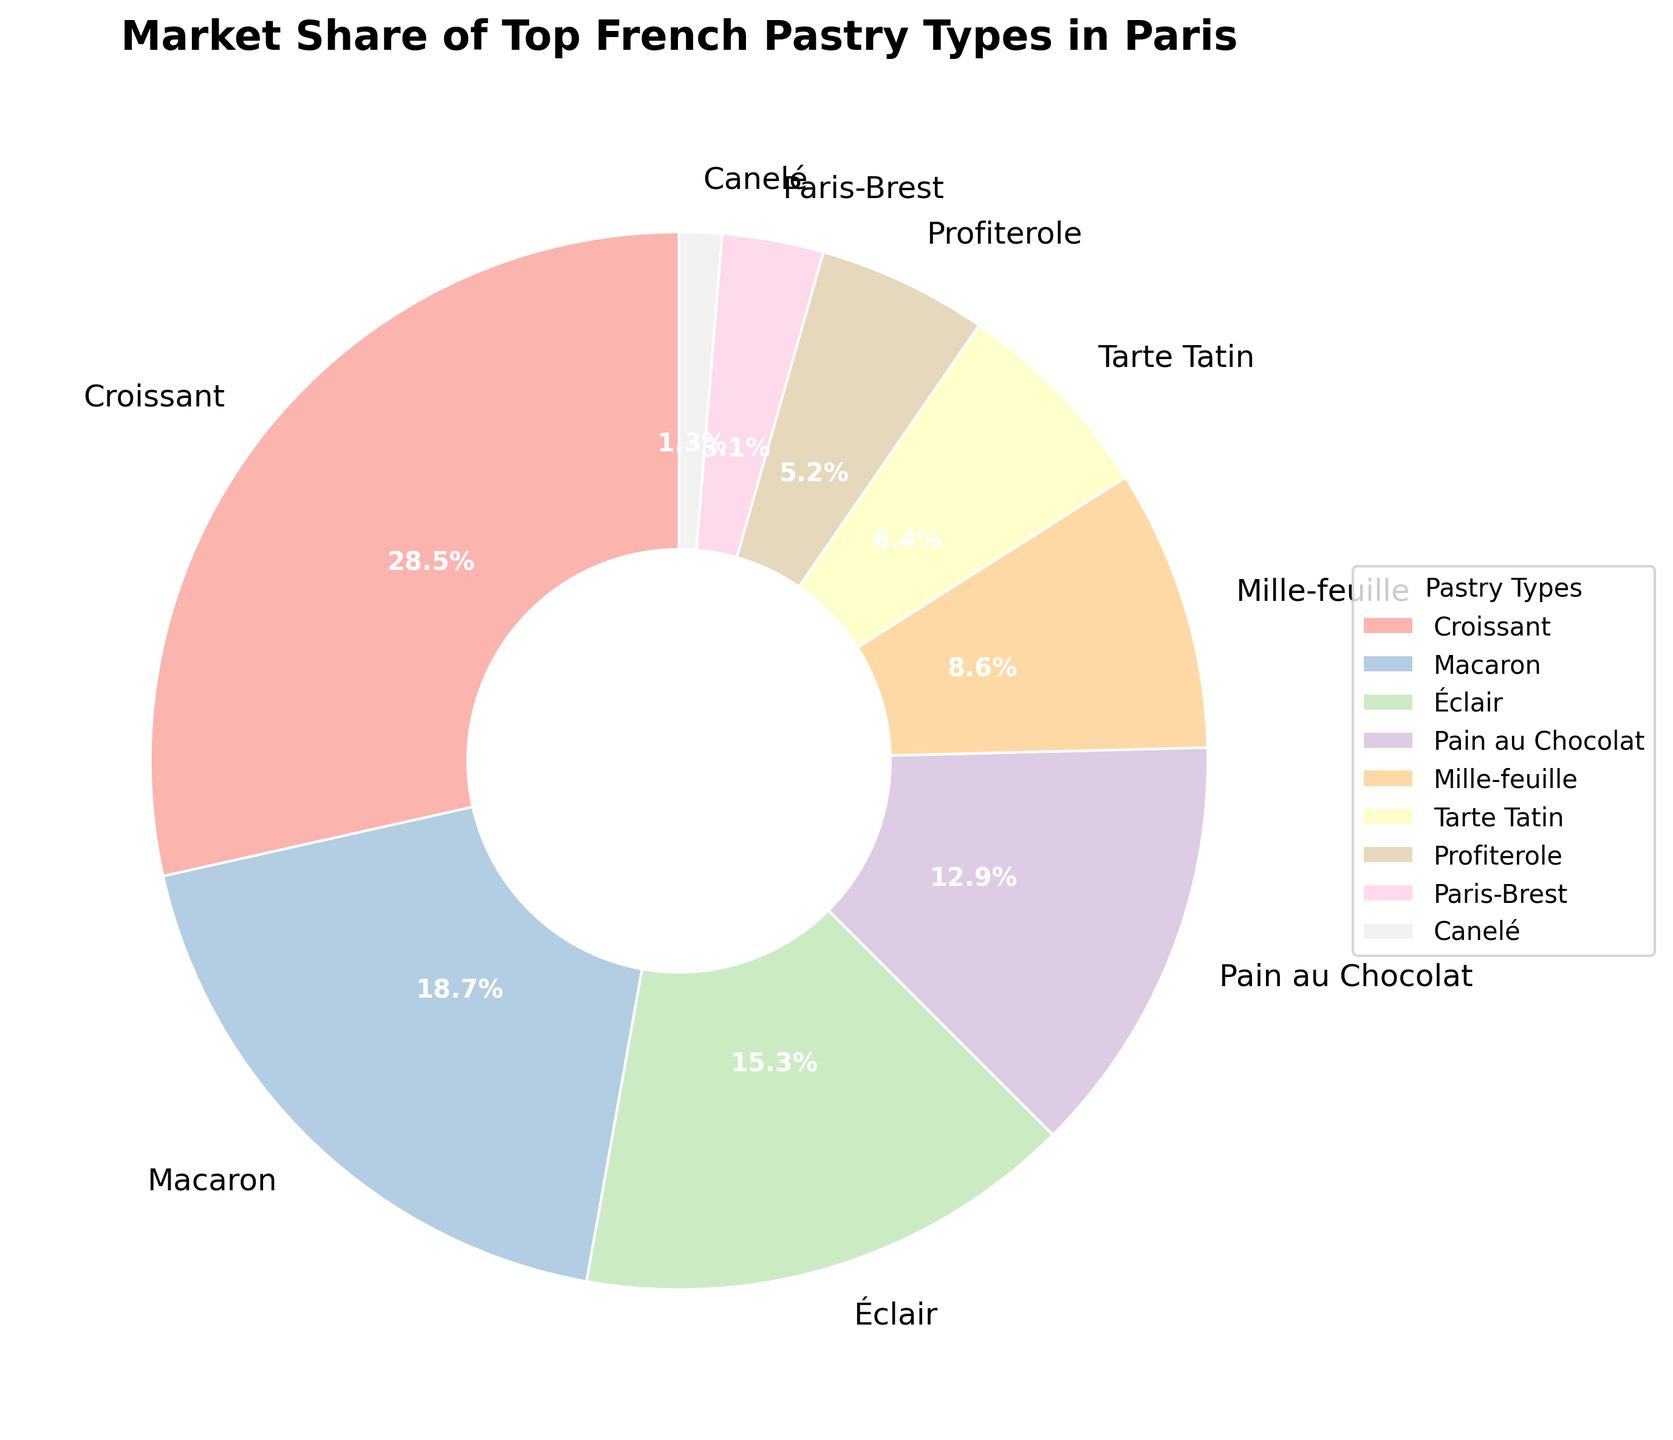What is the market share of Croissants? The figure lists the market shares of various French pastries. Locate the label "Croissant" and read its market share percentage.
Answer: 28.5% Which pastry has the lowest market share? Identify the slice with the smallest percentage value in the pie chart. This slice will represent the pastry with the lowest market share.
Answer: Canelé How much larger is the market share of Pain au Chocolat compared to Profiterole? Subtract the market share percentage of Profiterole from that of Pain au Chocolat: 12.9% - 5.2%
Answer: 7.7% What percentage of the market do Éclairs and Tarte Tatin capture together? Sum the market share percentages of Éclairs and Tarte Tatin: 15.3% + 6.4% = 21.7%
Answer: 21.7% What is the difference in market share between the pastry with the highest market share and the one with the lowest? Subtract the market share of Canelé from that of Croissant: 28.5% - 1.3% = 27.2%
Answer: 27.2% What is the sum of market shares for the bottom three pastry types? Add the market share percentages of Paris-Brest, Profiterole, and Canelé: 3.1% + 5.2% + 1.3% = 9.6%
Answer: 9.6% Is the market share of Macarons greater than that of Éclairs and Paris-Brest combined? Sum the market shares of Éclairs and Paris-Brest: 15.3% + 3.1% = 18.4%. Compare this with the market share of Macarons, which is 18.7%.
Answer: Yes Which two pastries have the closest market shares? Compare the market share percentages to find the two closest values. The closest shares are Paris-Brest (3.1%) and Canelé (1.3%) with a difference of 1.8%.
Answer: Paris-Brest and Canelé If you combine the market shares of the top three pastries, what percentage of the market is that? Add the market shares of Croissant, Macaron, and Éclair: 28.5% + 18.7% + 15.3% = 62.5%
Answer: 62.5% What color represents Éclairs in the chart? Locate Éclair in the legend and match its color to the corresponding slice in the pie chart. Since the pie chart uses a pastel color scheme, the specific pastel color representing Éclair can be identified visually.
Answer: [Identify color visually] 